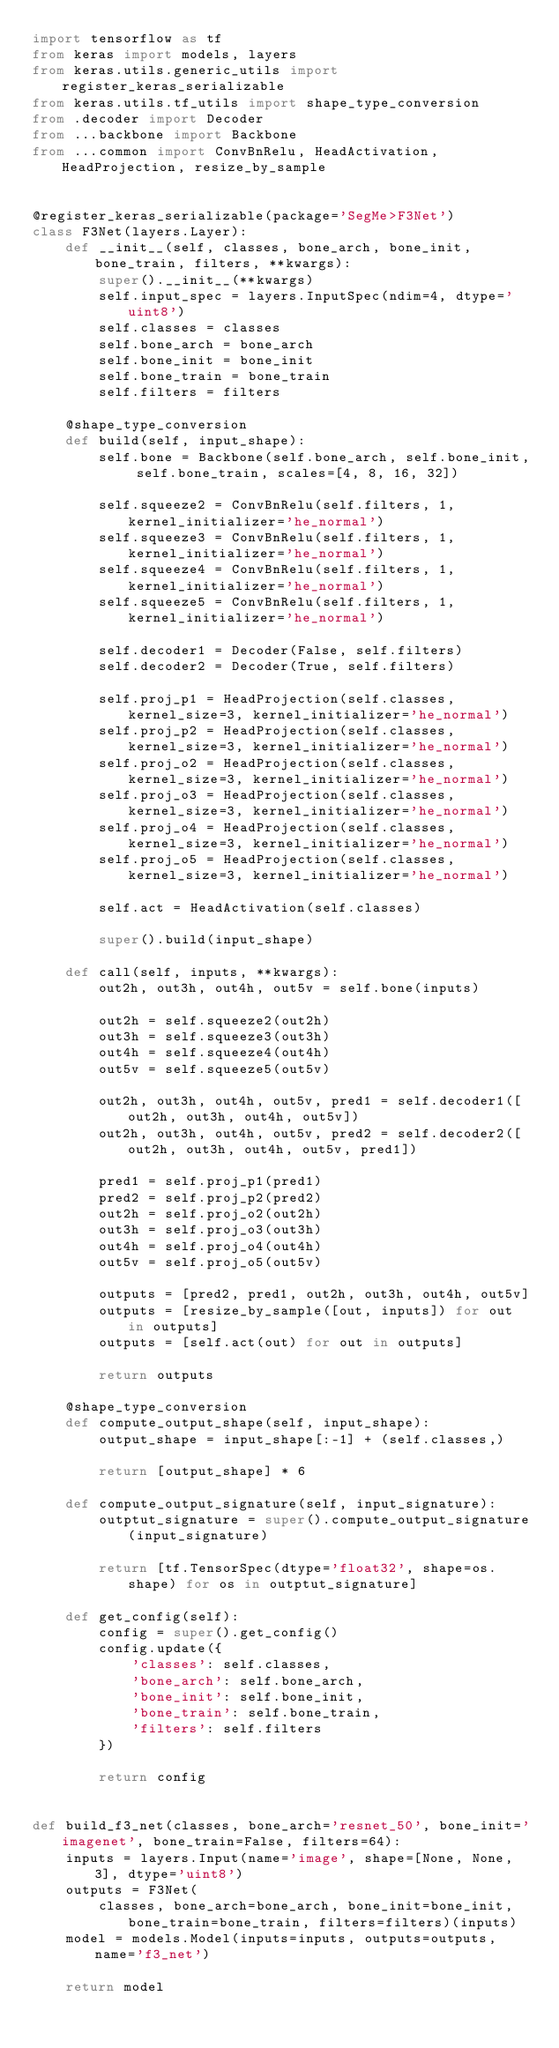<code> <loc_0><loc_0><loc_500><loc_500><_Python_>import tensorflow as tf
from keras import models, layers
from keras.utils.generic_utils import register_keras_serializable
from keras.utils.tf_utils import shape_type_conversion
from .decoder import Decoder
from ...backbone import Backbone
from ...common import ConvBnRelu, HeadActivation, HeadProjection, resize_by_sample


@register_keras_serializable(package='SegMe>F3Net')
class F3Net(layers.Layer):
    def __init__(self, classes, bone_arch, bone_init, bone_train, filters, **kwargs):
        super().__init__(**kwargs)
        self.input_spec = layers.InputSpec(ndim=4, dtype='uint8')
        self.classes = classes
        self.bone_arch = bone_arch
        self.bone_init = bone_init
        self.bone_train = bone_train
        self.filters = filters

    @shape_type_conversion
    def build(self, input_shape):
        self.bone = Backbone(self.bone_arch, self.bone_init, self.bone_train, scales=[4, 8, 16, 32])

        self.squeeze2 = ConvBnRelu(self.filters, 1, kernel_initializer='he_normal')
        self.squeeze3 = ConvBnRelu(self.filters, 1, kernel_initializer='he_normal')
        self.squeeze4 = ConvBnRelu(self.filters, 1, kernel_initializer='he_normal')
        self.squeeze5 = ConvBnRelu(self.filters, 1, kernel_initializer='he_normal')

        self.decoder1 = Decoder(False, self.filters)
        self.decoder2 = Decoder(True, self.filters)

        self.proj_p1 = HeadProjection(self.classes, kernel_size=3, kernel_initializer='he_normal')
        self.proj_p2 = HeadProjection(self.classes, kernel_size=3, kernel_initializer='he_normal')
        self.proj_o2 = HeadProjection(self.classes, kernel_size=3, kernel_initializer='he_normal')
        self.proj_o3 = HeadProjection(self.classes, kernel_size=3, kernel_initializer='he_normal')
        self.proj_o4 = HeadProjection(self.classes, kernel_size=3, kernel_initializer='he_normal')
        self.proj_o5 = HeadProjection(self.classes, kernel_size=3, kernel_initializer='he_normal')

        self.act = HeadActivation(self.classes)

        super().build(input_shape)

    def call(self, inputs, **kwargs):
        out2h, out3h, out4h, out5v = self.bone(inputs)

        out2h = self.squeeze2(out2h)
        out3h = self.squeeze3(out3h)
        out4h = self.squeeze4(out4h)
        out5v = self.squeeze5(out5v)

        out2h, out3h, out4h, out5v, pred1 = self.decoder1([out2h, out3h, out4h, out5v])
        out2h, out3h, out4h, out5v, pred2 = self.decoder2([out2h, out3h, out4h, out5v, pred1])

        pred1 = self.proj_p1(pred1)
        pred2 = self.proj_p2(pred2)
        out2h = self.proj_o2(out2h)
        out3h = self.proj_o3(out3h)
        out4h = self.proj_o4(out4h)
        out5v = self.proj_o5(out5v)

        outputs = [pred2, pred1, out2h, out3h, out4h, out5v]
        outputs = [resize_by_sample([out, inputs]) for out in outputs]
        outputs = [self.act(out) for out in outputs]

        return outputs

    @shape_type_conversion
    def compute_output_shape(self, input_shape):
        output_shape = input_shape[:-1] + (self.classes,)

        return [output_shape] * 6

    def compute_output_signature(self, input_signature):
        outptut_signature = super().compute_output_signature(input_signature)

        return [tf.TensorSpec(dtype='float32', shape=os.shape) for os in outptut_signature]

    def get_config(self):
        config = super().get_config()
        config.update({
            'classes': self.classes,
            'bone_arch': self.bone_arch,
            'bone_init': self.bone_init,
            'bone_train': self.bone_train,
            'filters': self.filters
        })

        return config


def build_f3_net(classes, bone_arch='resnet_50', bone_init='imagenet', bone_train=False, filters=64):
    inputs = layers.Input(name='image', shape=[None, None, 3], dtype='uint8')
    outputs = F3Net(
        classes, bone_arch=bone_arch, bone_init=bone_init, bone_train=bone_train, filters=filters)(inputs)
    model = models.Model(inputs=inputs, outputs=outputs, name='f3_net')

    return model
</code> 